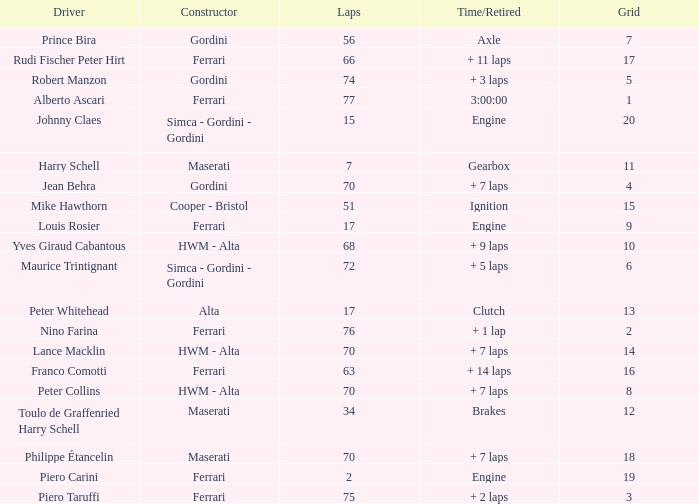How many grids for peter collins? 1.0. 